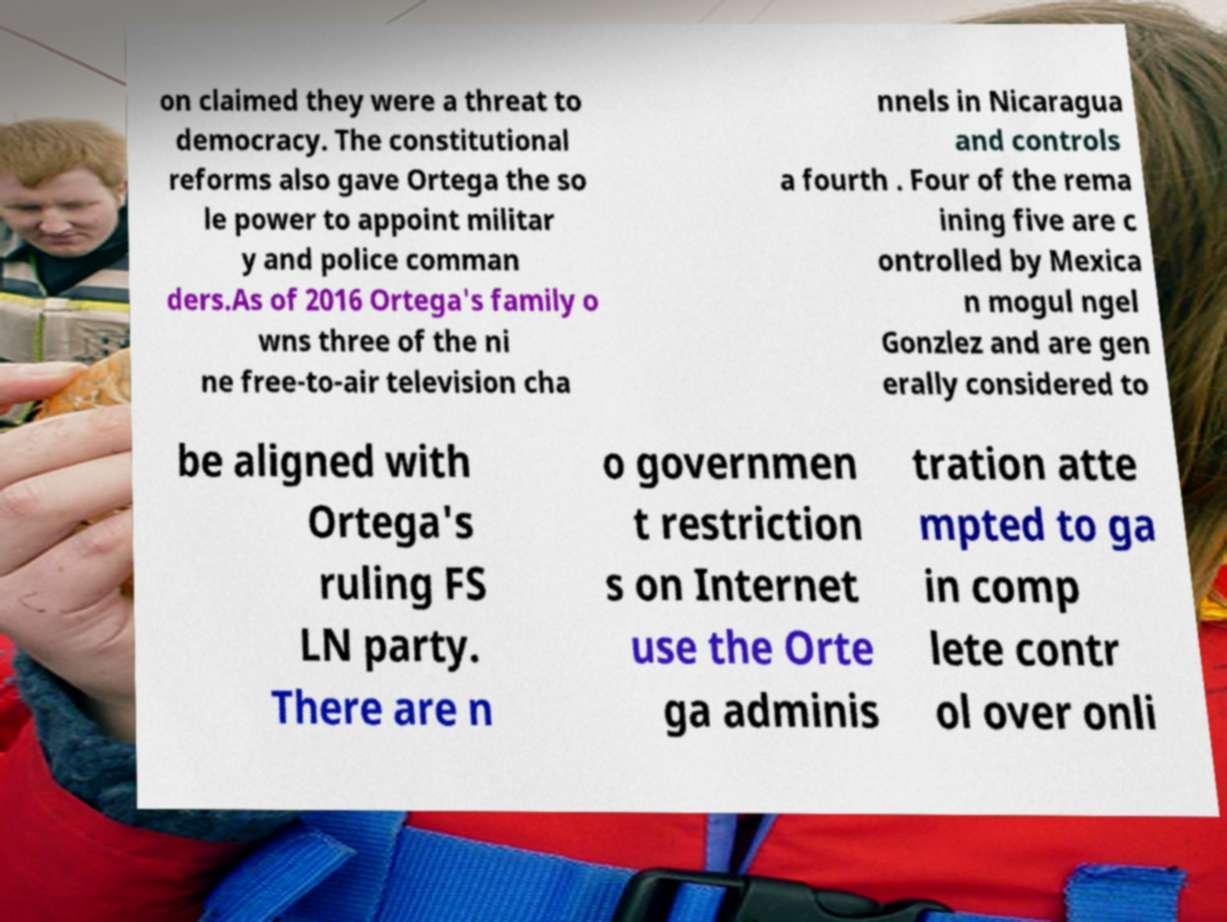There's text embedded in this image that I need extracted. Can you transcribe it verbatim? on claimed they were a threat to democracy. The constitutional reforms also gave Ortega the so le power to appoint militar y and police comman ders.As of 2016 Ortega's family o wns three of the ni ne free-to-air television cha nnels in Nicaragua and controls a fourth . Four of the rema ining five are c ontrolled by Mexica n mogul ngel Gonzlez and are gen erally considered to be aligned with Ortega's ruling FS LN party. There are n o governmen t restriction s on Internet use the Orte ga adminis tration atte mpted to ga in comp lete contr ol over onli 